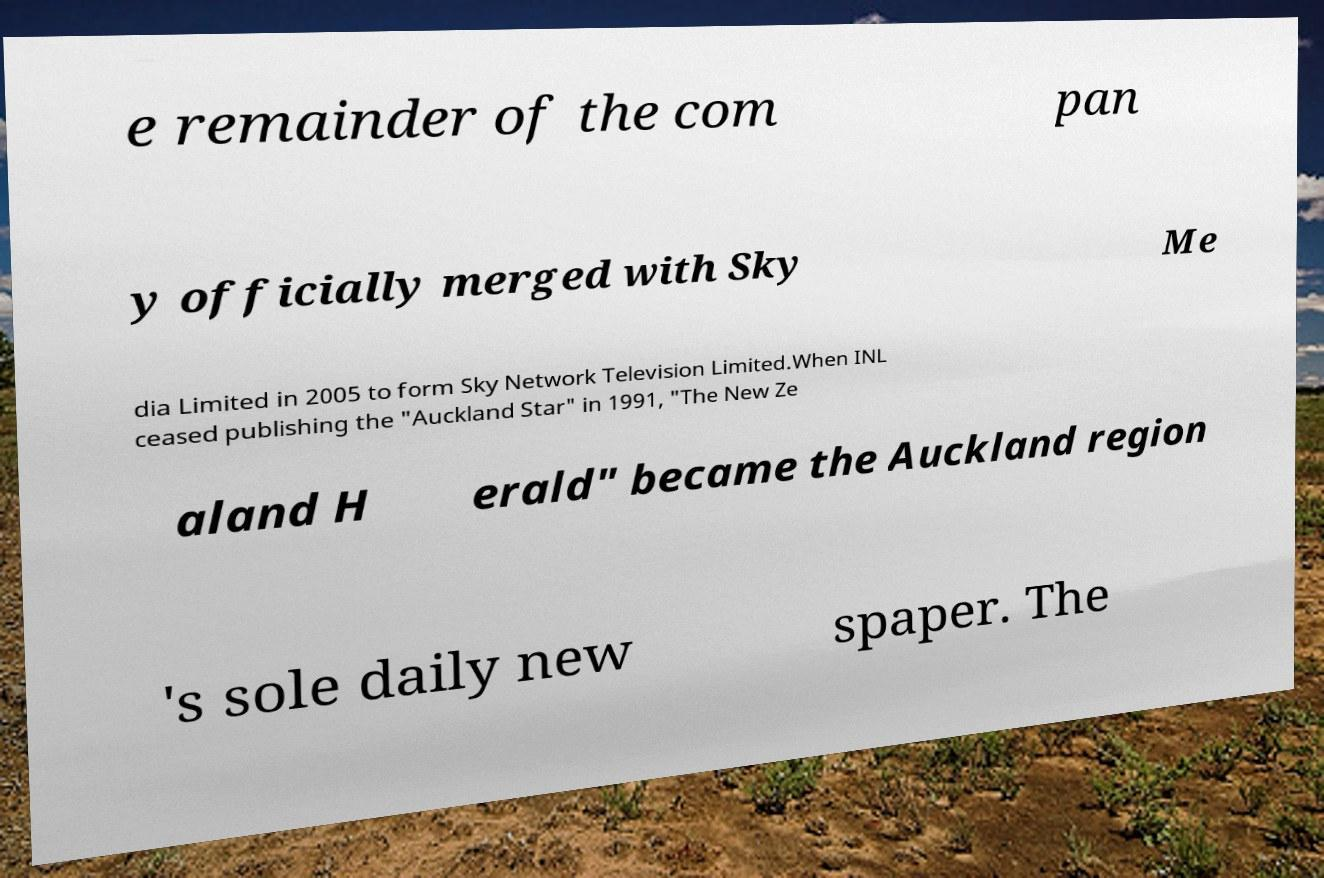There's text embedded in this image that I need extracted. Can you transcribe it verbatim? e remainder of the com pan y officially merged with Sky Me dia Limited in 2005 to form Sky Network Television Limited.When INL ceased publishing the "Auckland Star" in 1991, "The New Ze aland H erald" became the Auckland region 's sole daily new spaper. The 